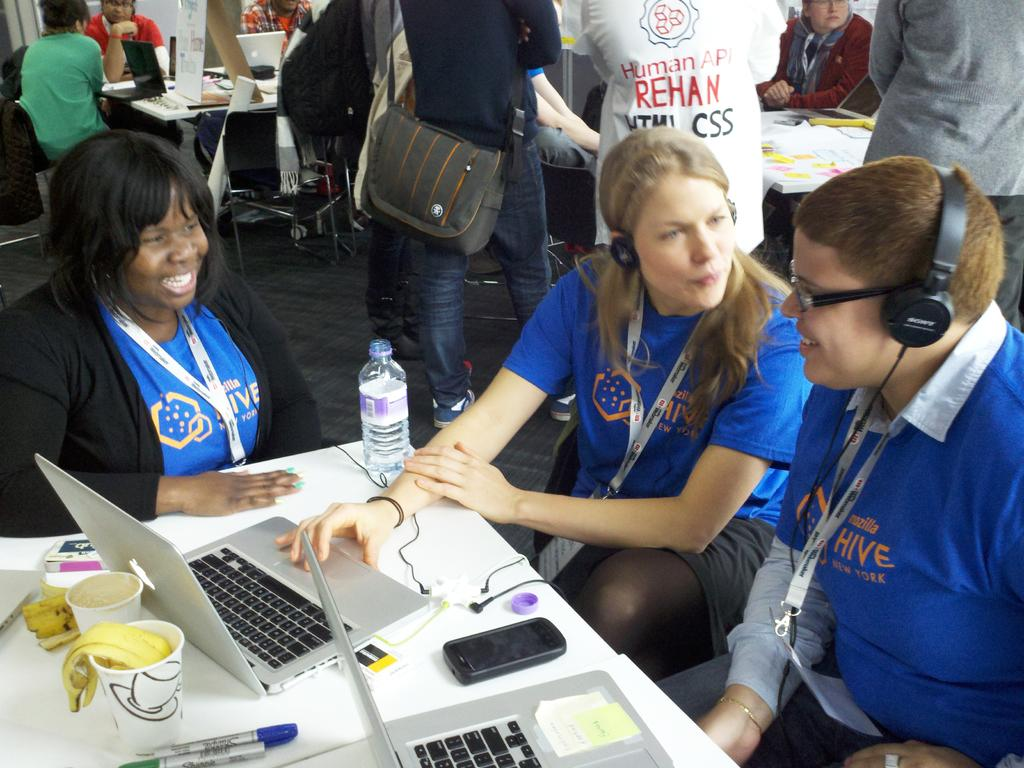What are the three persons in the middle of the image doing? The three persons in the middle of the image are sitting and talking. What objects can be seen on the left side of the image? There are laptops on a table on the left side of the image. Can you describe the people visible at the top of the image? Unfortunately, the provided facts do not give any information about the people visible at the top of the image. What is the name of the month in which the net is being used in the image? There is no net present in the image, so it is not possible to determine the month in which it might be used. 